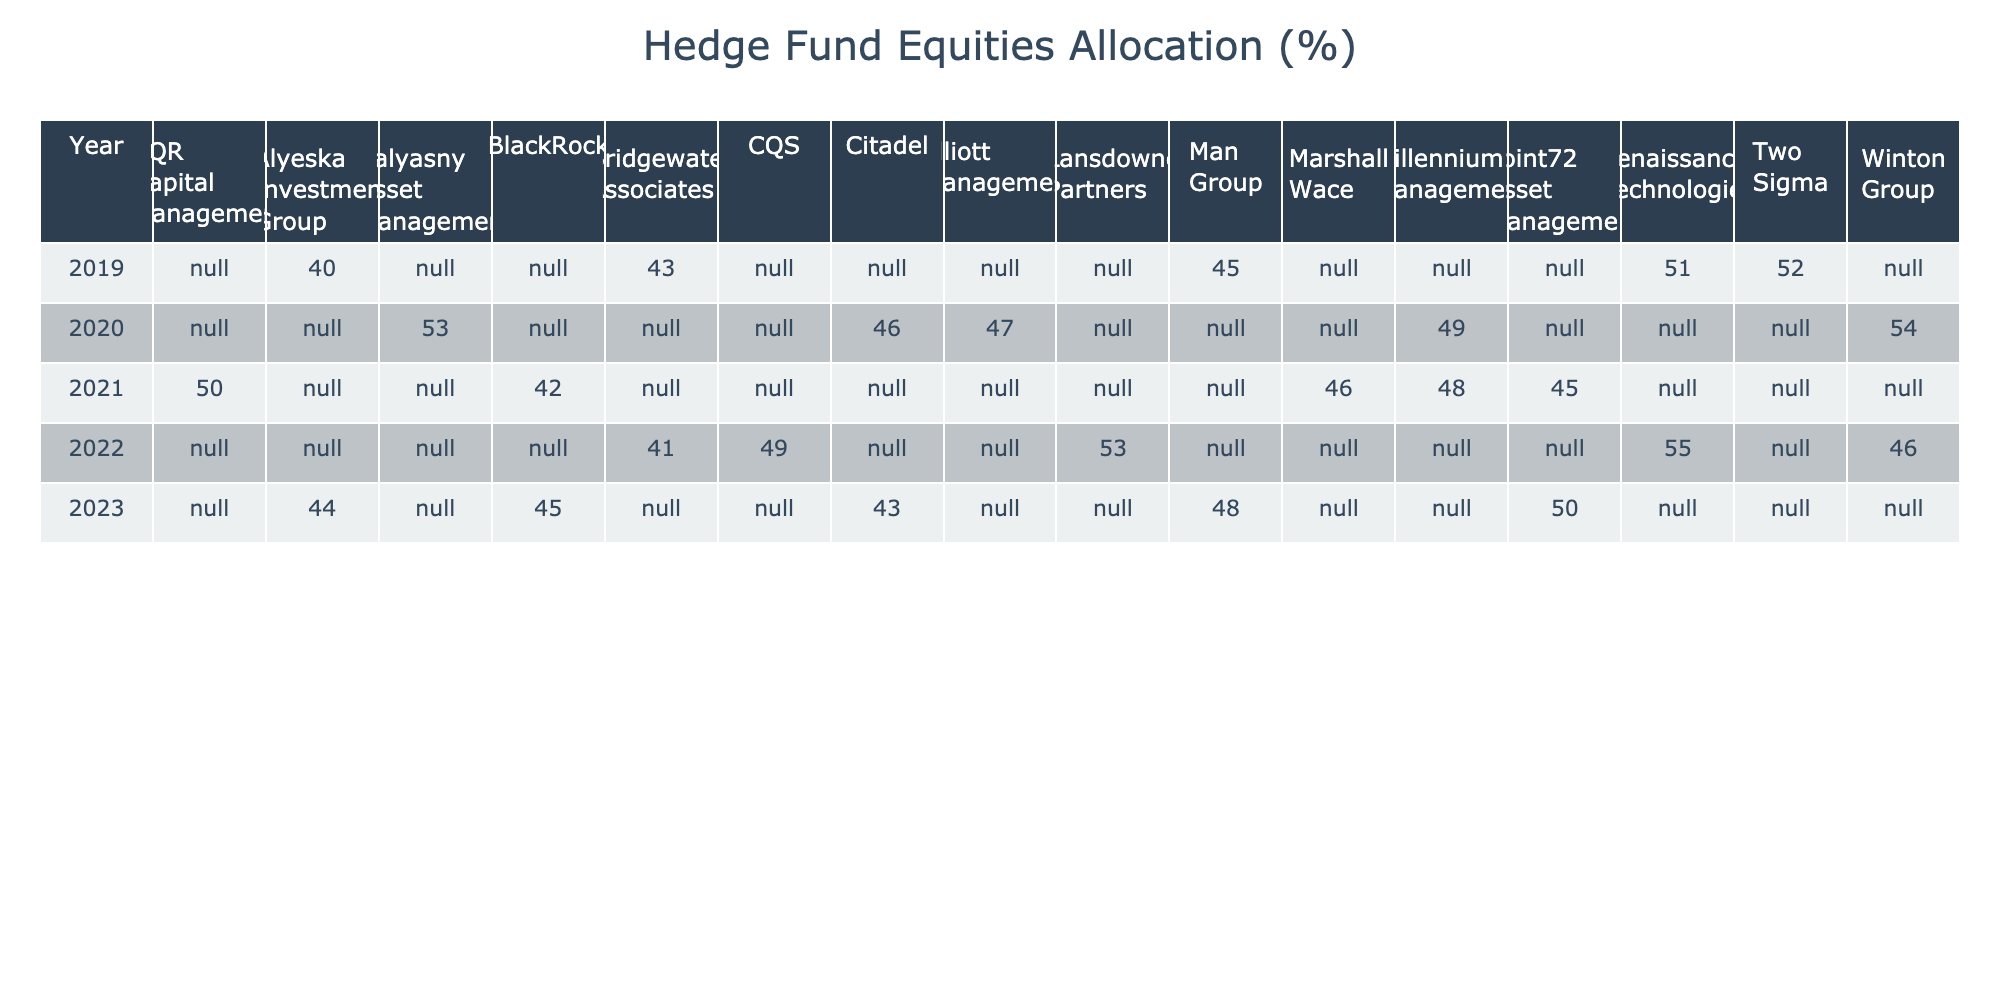What was the equities allocation of Renaissance Technologies in 2022? The table shows that the equities allocation for Renaissance Technologies in 2022 was 55.
Answer: 55 Which hedge fund had the highest fixed income allocation in 2020? By looking through the 2020 row, Balyasny Asset Management had a fixed income allocation of 30%, which is the highest for that year among the listed funds.
Answer: Balyasny Asset Management What is the total cash allocation across all hedge funds for the year 2021? The cash allocations for 2021 are as follows: Point72 (5), BlackRock (5), Millennium Management (6), AQR (5), and Marshall Wace (6). Adding these gives a total of 5 + 5 + 6 + 5 + 6 = 27.
Answer: 27 Did Citadel's equities allocation increase or decrease from 2020 to 2023? Citadel's allocation in 2020 was 46% and in 2023 it was 43%. Thus, the allocation decreased from 46% to 43%.
Answer: Decrease Which hedge fund had the lowest alternative assets allocation in 2023? In 2023, Alyeska Investment Group had an alternative assets allocation of 20%, which is the lowest compared to other hedge funds in that year.
Answer: Alyeska Investment Group What was the average equities allocation across all hedge funds for the year 2019? The equities allocations for 2019 are: Bridgewater (43), Renaissance (51), Man Group (45), Alyeska (40), and Two Sigma (52). To find the average, we sum these: 43 + 51 + 45 + 40 + 52 = 231, and then divide by the number of hedge funds (5). The average is 231 / 5 = 46.2.
Answer: 46.2 Is it true that all hedge funds allocated less than 30% to cash in 2020? Checking the cash allocations for hedge funds in 2020 shows that Balyasny Asset Management and Winton Group both had a 5% allocation, which is less than 30%, making the statement true.
Answer: Yes What is the difference in equities allocation between the highest and lowest hedge funds in 2021? In 2021, the highest allocation is 50% for AQR Capital Management and the lowest is 42% for BlackRock. The difference is 50 - 42 = 8%.
Answer: 8% 